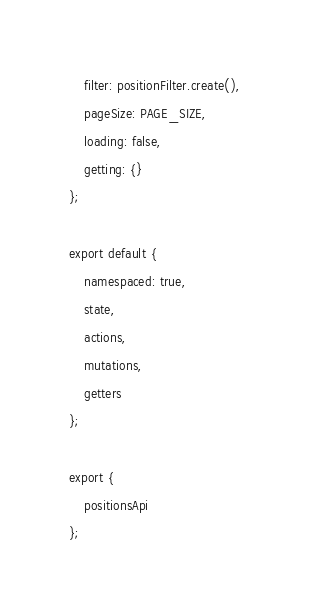Convert code to text. <code><loc_0><loc_0><loc_500><loc_500><_JavaScript_>    filter: positionFilter.create(),
    pageSize: PAGE_SIZE,
    loading: false,
    getting: {}
};

export default {
    namespaced: true,
    state,
    actions,
    mutations,
    getters
};

export {
    positionsApi
};
</code> 